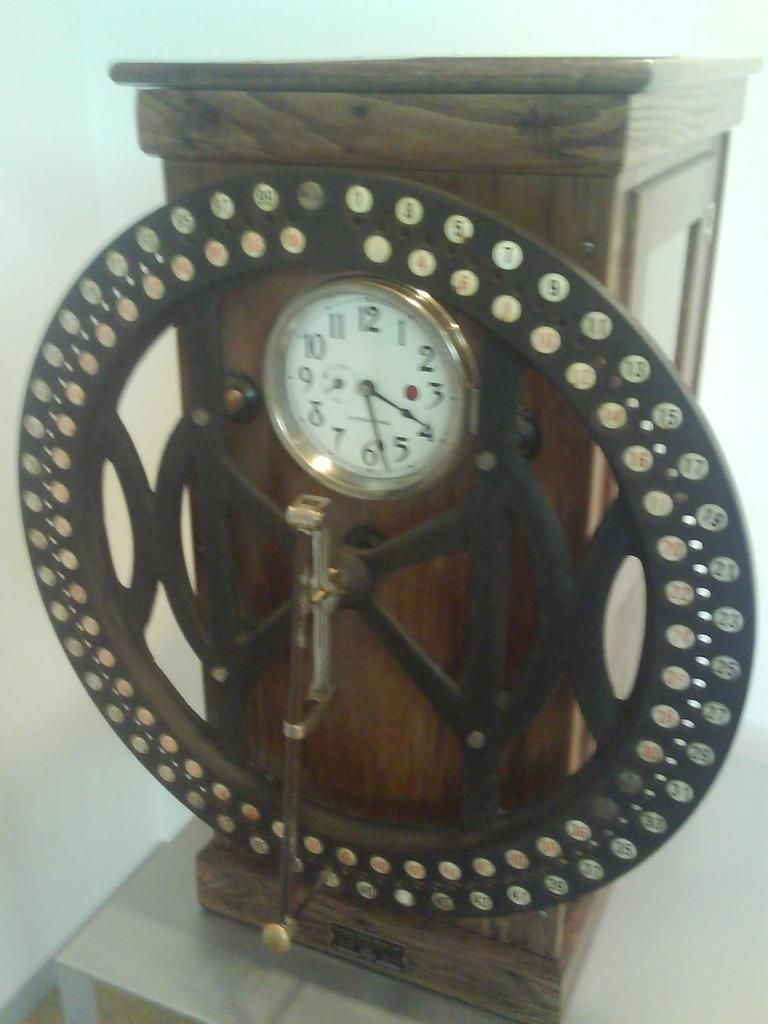<image>
Present a compact description of the photo's key features. A clock built into something else that shows it is almost four thirty. 